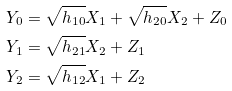Convert formula to latex. <formula><loc_0><loc_0><loc_500><loc_500>Y _ { 0 } & = \sqrt { h _ { 1 0 } } X _ { 1 } + \sqrt { h _ { 2 0 } } X _ { 2 } + Z _ { 0 } \\ Y _ { 1 } & = \sqrt { h _ { 2 1 } } X _ { 2 } + Z _ { 1 } \\ Y _ { 2 } & = \sqrt { h _ { 1 2 } } X _ { 1 } + Z _ { 2 }</formula> 